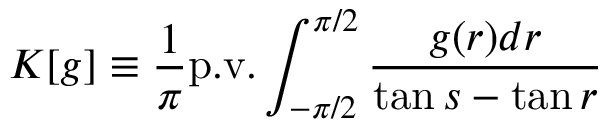Convert formula to latex. <formula><loc_0><loc_0><loc_500><loc_500>K [ g ] \equiv \frac { 1 } { \pi } p . v . \int _ { - \pi / 2 } ^ { \pi / 2 } \frac { g ( r ) d r } { \tan s - \tan r }</formula> 